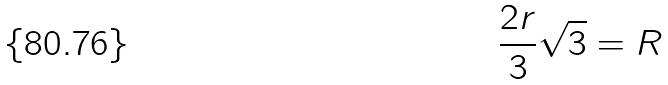Convert formula to latex. <formula><loc_0><loc_0><loc_500><loc_500>\frac { 2 r } { 3 } \sqrt { 3 } = R</formula> 